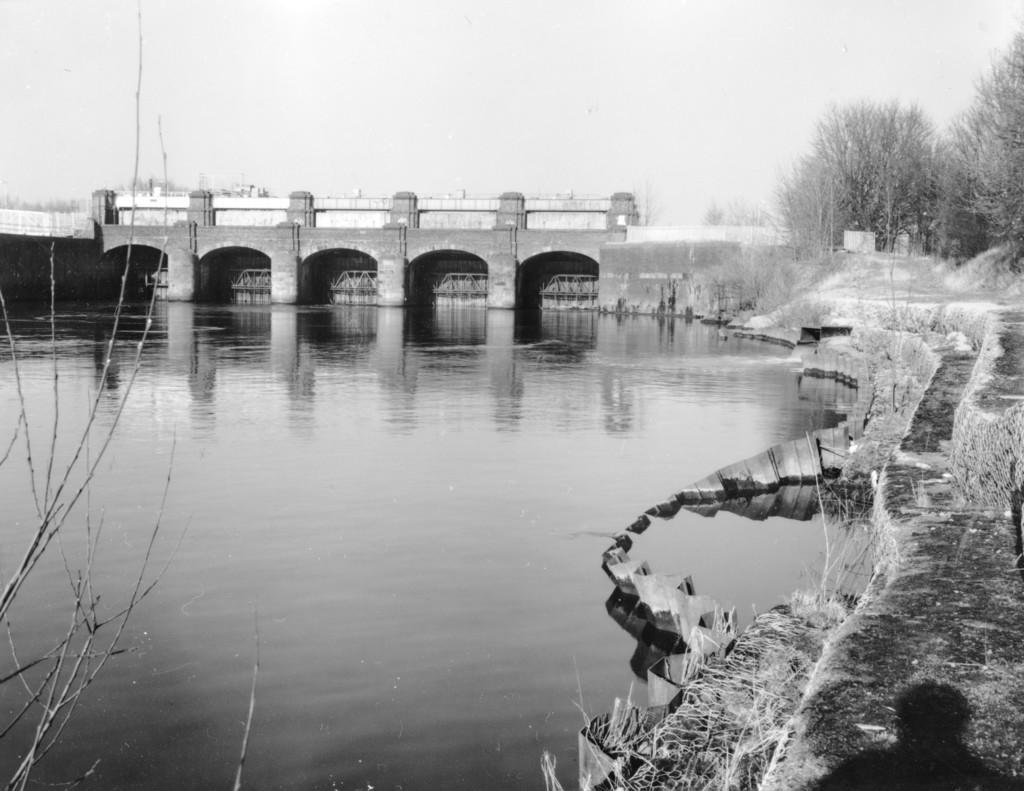In one or two sentences, can you explain what this image depicts? This is a black and white image. In the center of the image there is a bridge. There is water. To the right side of the image there are staircase. There are trees. 